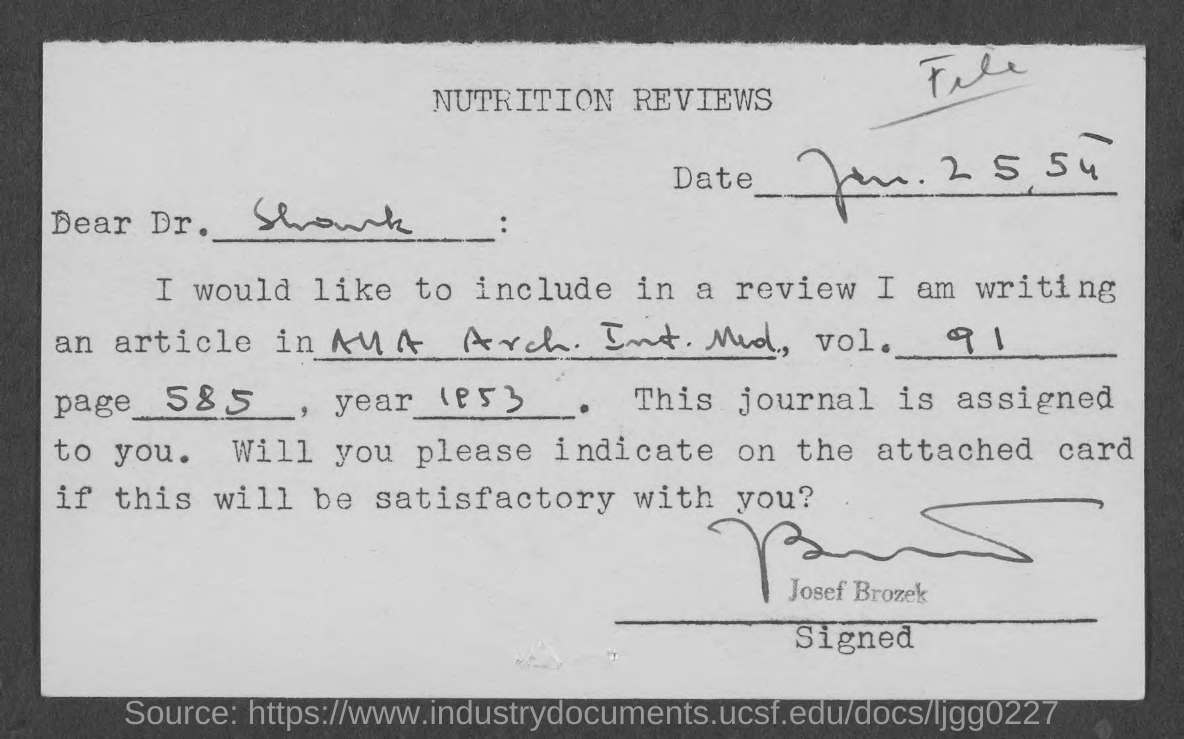What is this document about?
Your answer should be very brief. Nutrition reviews. Who has signed this document?
Ensure brevity in your answer.  Josef brozek. To whom, the document is addressed?
Provide a short and direct response. Dr. Shank. What is the date mentioned in this document?
Offer a terse response. Jan.25,54. What is the page no of the article mentioned in this document?
Give a very brief answer. Page 585. What is the vol. no of the article given in the document?
Your answer should be very brief. 91. 